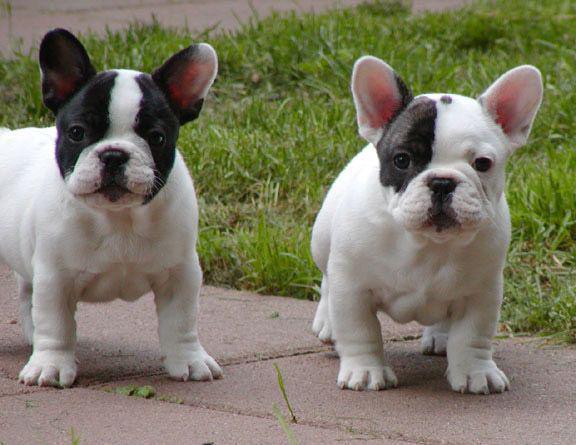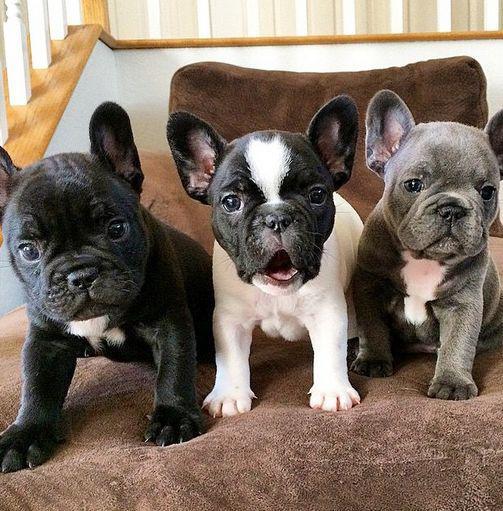The first image is the image on the left, the second image is the image on the right. For the images displayed, is the sentence "In one of the images, the dogs are standing on the pavement outside." factually correct? Answer yes or no. Yes. The first image is the image on the left, the second image is the image on the right. Given the left and right images, does the statement "An image shows a horizontal row of three similarly colored dogs in similar poses." hold true? Answer yes or no. No. 